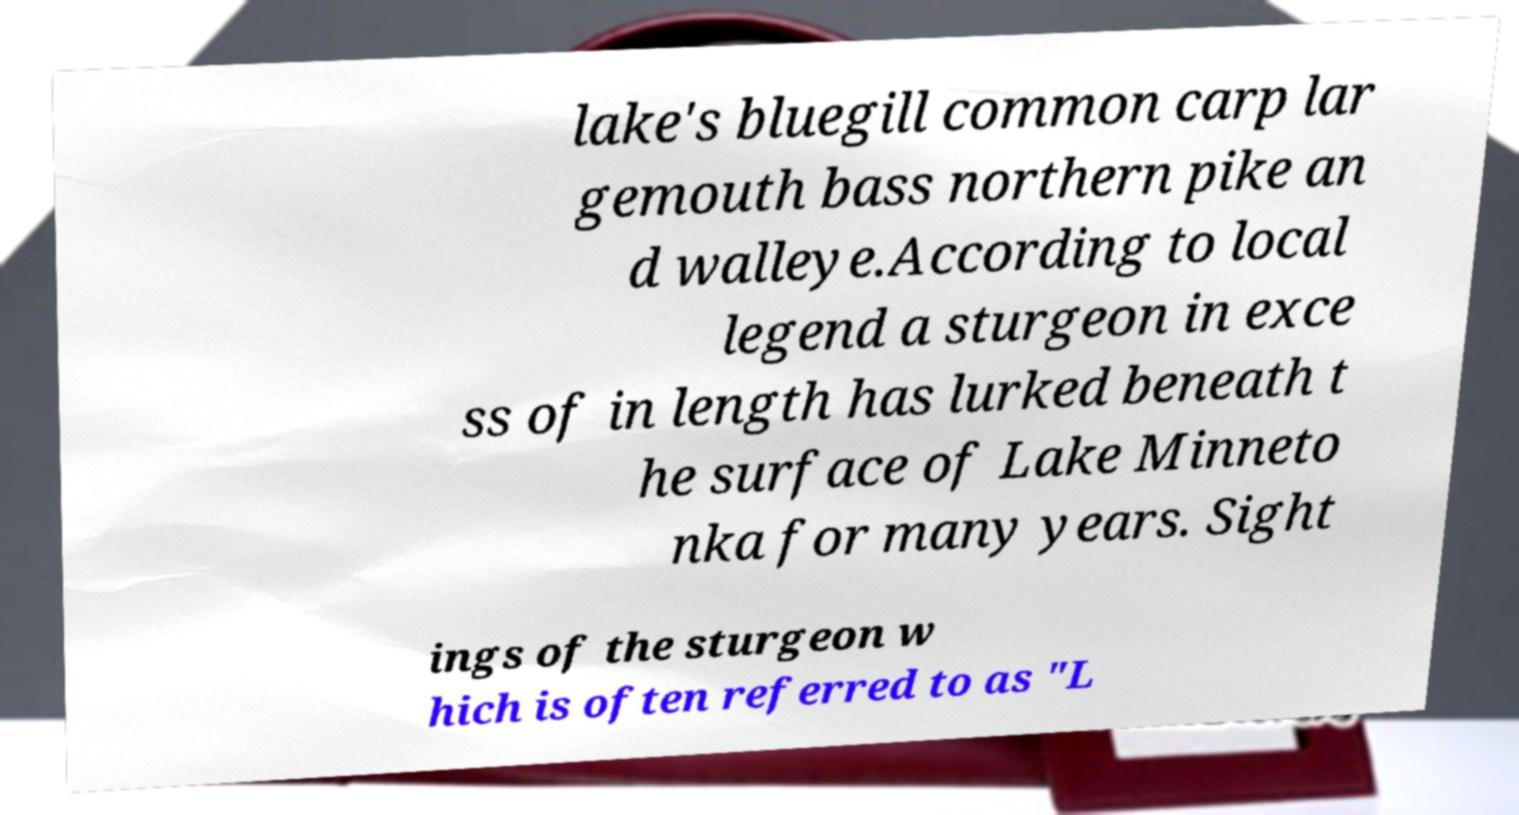Could you assist in decoding the text presented in this image and type it out clearly? lake's bluegill common carp lar gemouth bass northern pike an d walleye.According to local legend a sturgeon in exce ss of in length has lurked beneath t he surface of Lake Minneto nka for many years. Sight ings of the sturgeon w hich is often referred to as "L 